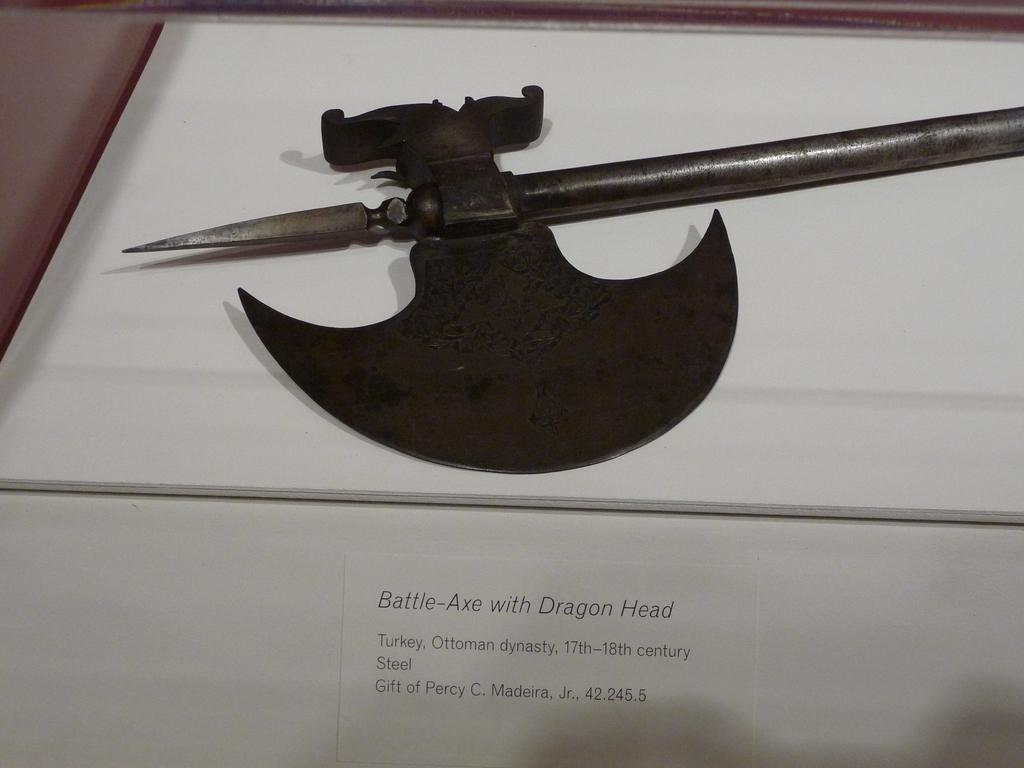What weapon is present in the image? There is a battle-axe in the image. How is the battle-axe positioned in the image? The battle-axe is resting on a surface. What else can be seen on the surface? There is text on the surface. What type of yoke is used to control the battle-axe in the image? There is no yoke present in the image, and the battle-axe is not being controlled by any external force. 